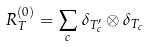<formula> <loc_0><loc_0><loc_500><loc_500>R _ { T } ^ { ( 0 ) } = \sum _ { c } \, \delta _ { T ^ { \prime } _ { c } } \otimes \delta _ { T _ { c } }</formula> 